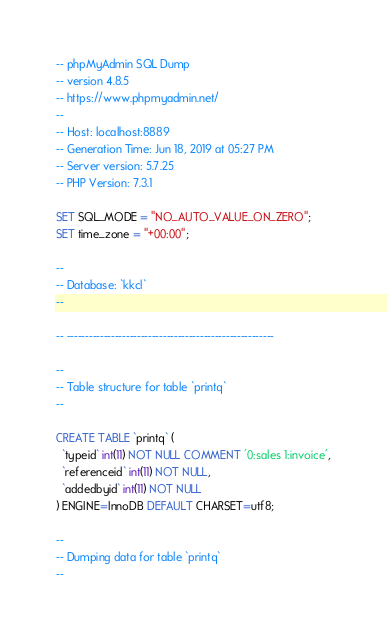<code> <loc_0><loc_0><loc_500><loc_500><_SQL_>-- phpMyAdmin SQL Dump
-- version 4.8.5
-- https://www.phpmyadmin.net/
--
-- Host: localhost:8889
-- Generation Time: Jun 18, 2019 at 05:27 PM
-- Server version: 5.7.25
-- PHP Version: 7.3.1

SET SQL_MODE = "NO_AUTO_VALUE_ON_ZERO";
SET time_zone = "+00:00";

--
-- Database: `kkcl`
--

-- --------------------------------------------------------

--
-- Table structure for table `printq`
--

CREATE TABLE `printq` (
  `typeid` int(11) NOT NULL COMMENT '0:sales 1:invoice',
  `referenceid` int(11) NOT NULL,
  `addedbyid` int(11) NOT NULL
) ENGINE=InnoDB DEFAULT CHARSET=utf8;

--
-- Dumping data for table `printq`
--
</code> 